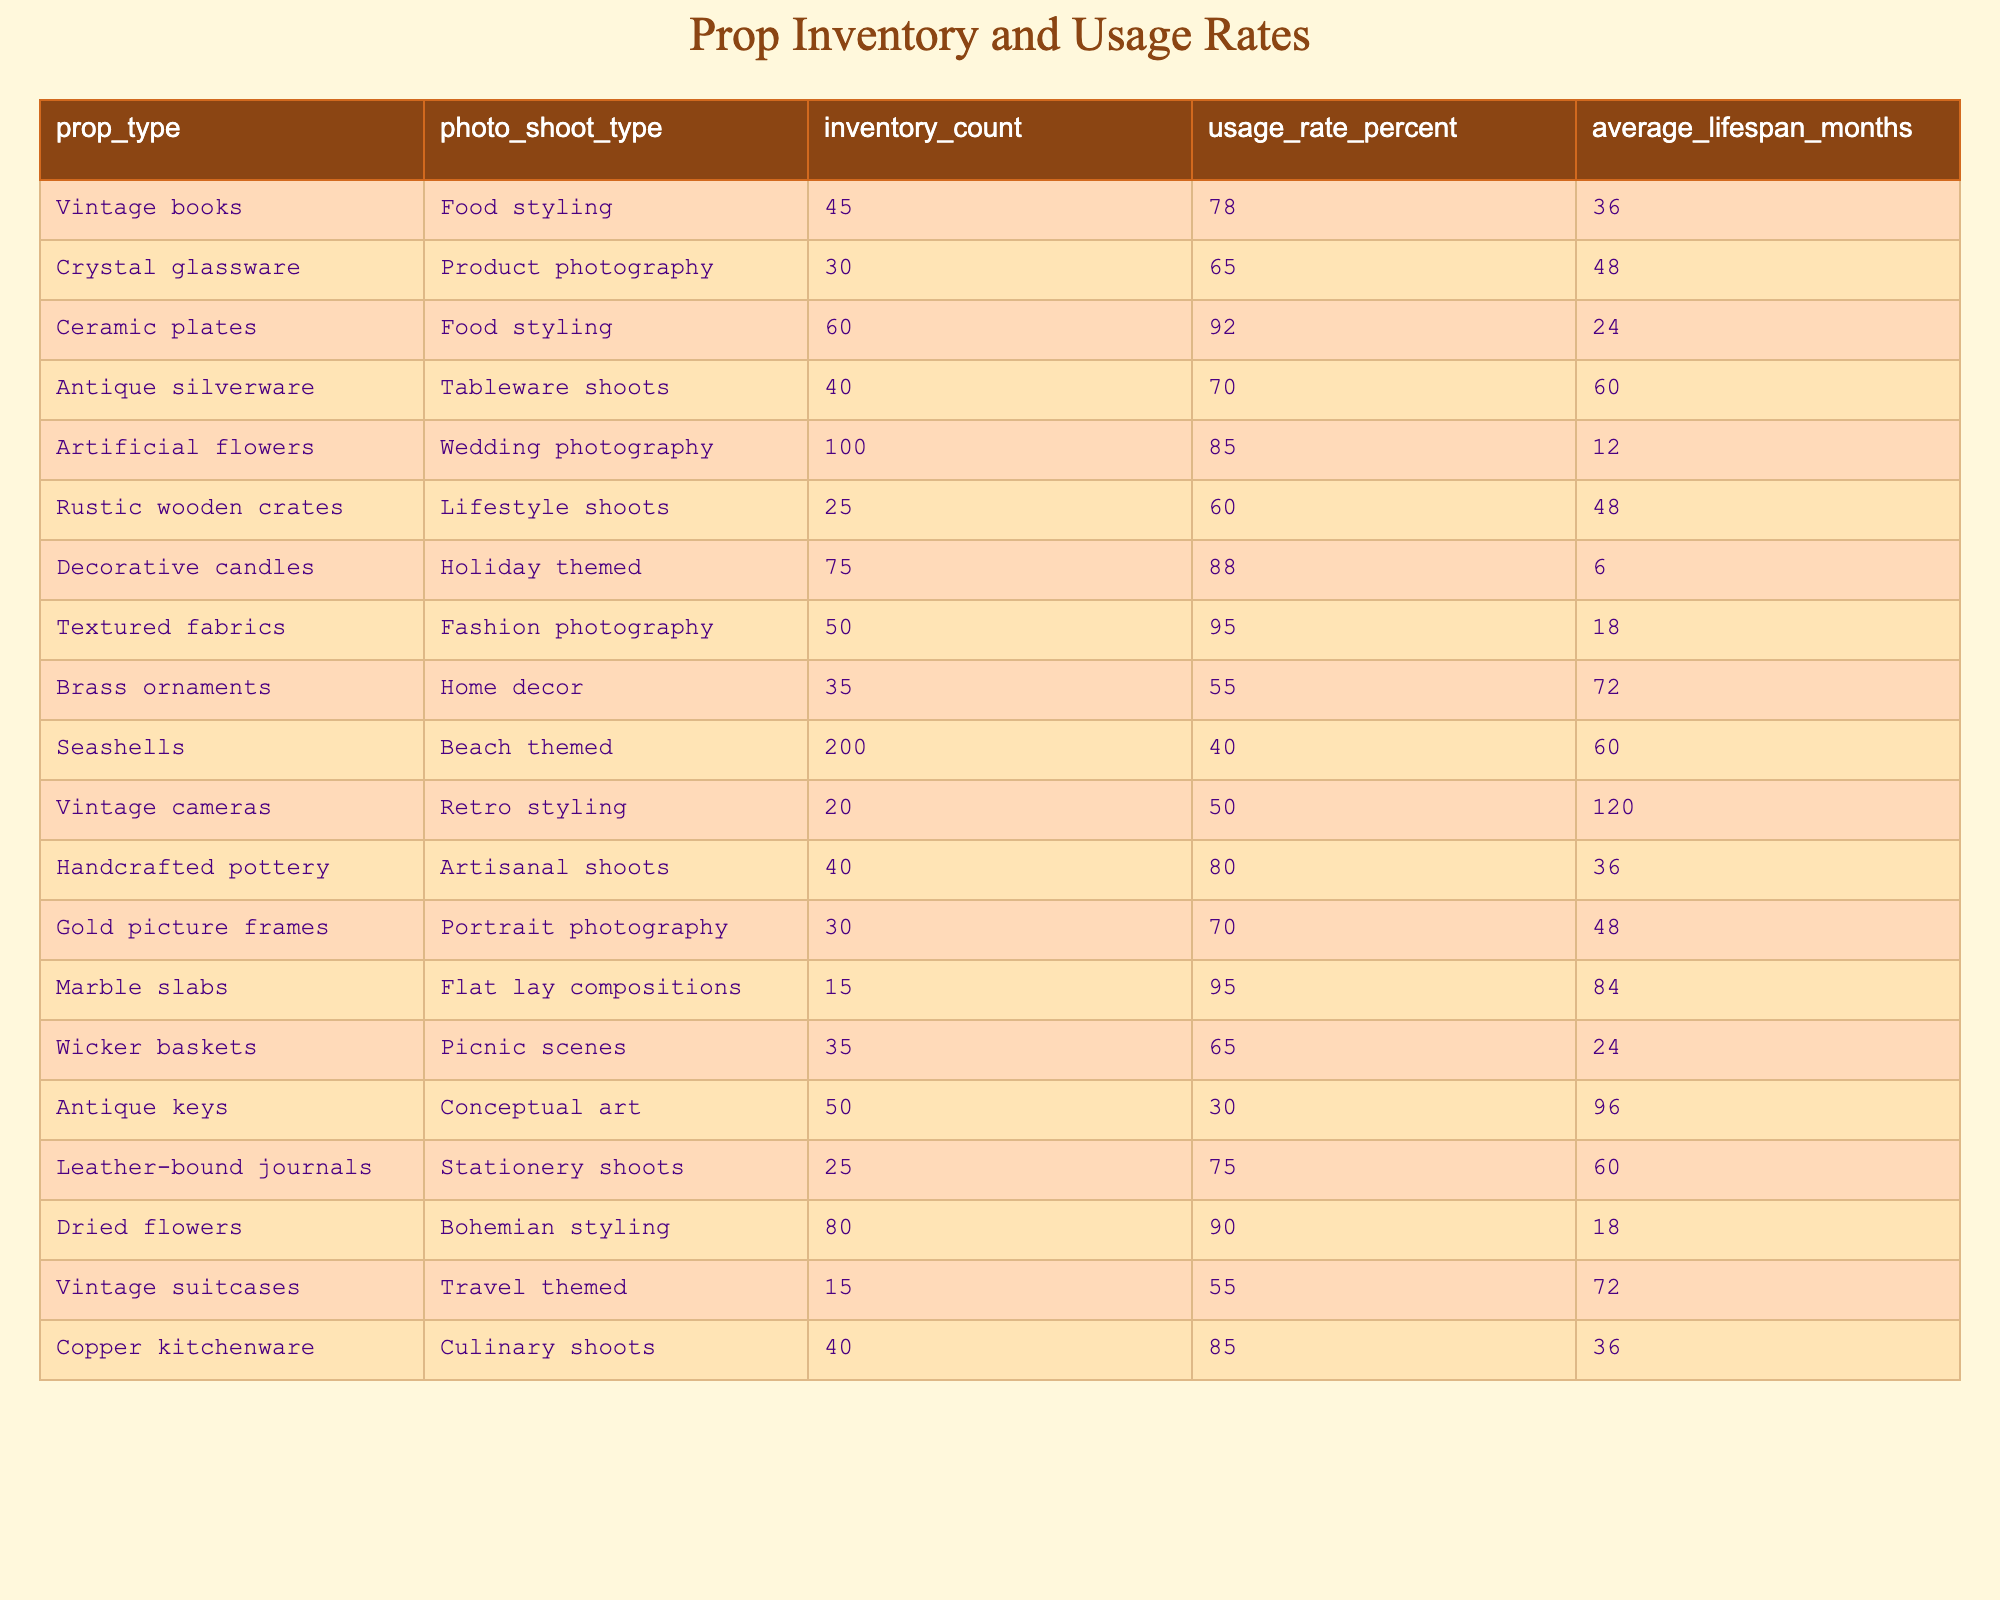What is the usage rate percentage for Ceramic plates in Food styling? Looking at the table, the usage rate percentage for Ceramic plates under the Food styling category is listed as 92%.
Answer: 92% Which prop type has the highest inventory count? By scanning through the inventory counts in the table, Seashells has the highest inventory count at 200.
Answer: 200 What percentage of Antique keys is used in Conceptual art photo shoots? The table specifies that the usage rate percentage for Antique keys in Conceptual art is 30%.
Answer: 30% Calculate the average usage rate percentage for all props used in Food styling. The props used in Food styling are Vintage books and Ceramic plates, with usage rates of 78% and 92%, respectively. The average is calculated as (78 + 92) / 2 = 85%.
Answer: 85% Is the average lifespan of Artificial flowers shorter than that of Decorative candles? The average lifespan of Artificial flowers is 12 months, while Decorative candles have an average lifespan of 6 months. Since 12 is longer than 6, the statement is false.
Answer: No How much higher is the usage rate of Textured fabrics in Fashion photography compared to the usage rate of Brass ornaments in Home decor? The usage rate for Textured fabrics is 95%, and for Brass ornaments, it's 55%. The difference is 95 - 55 = 40%. Thus, Textured fabrics have a higher usage rate by 40%.
Answer: 40% What is the total inventory count of props used in Wedding photography and Lifestyle shoots? The total inventory count includes Artificial flowers (100) for Wedding photography and Rustic wooden crates (25) for Lifestyle shoots. Summing these gives 100 + 25 = 125.
Answer: 125 Which photo shoot type has the longest lifespan for its props, and what is that lifespan? The longest lifespan for props is found under the Tableware shoots category, with Antique silverware having an average lifespan of 60 months.
Answer: Tableware shoots, 60 months Are there more Decorative candles or Rustic wooden crates available? Checking the table, Decorative candles inventory count is 75, while Rustic wooden crates inventory count is 25. Therefore, there are more Decorative candles available.
Answer: Yes What is the average lifespan of props used in Culinary shoots? There is only one prop for Culinary shoots, which is Copper kitchenware with an average lifespan of 36 months. Hence, the average is simply 36 months.
Answer: 36 months 